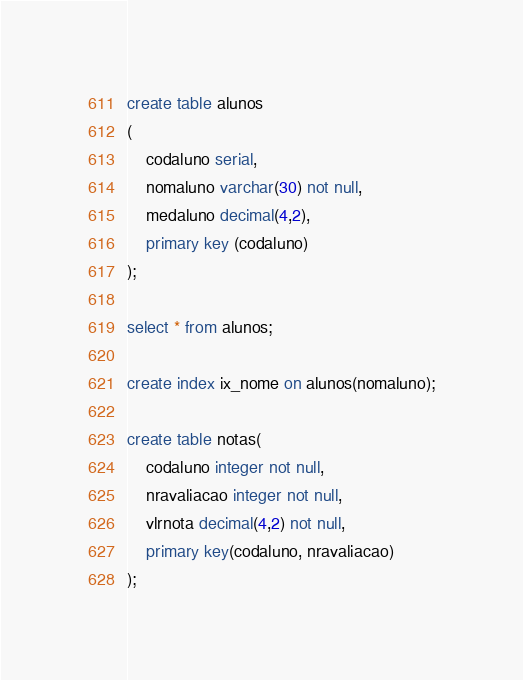Convert code to text. <code><loc_0><loc_0><loc_500><loc_500><_SQL_>create table alunos
(
	codaluno serial,
	nomaluno varchar(30) not null,
	medaluno decimal(4,2),
	primary key (codaluno)
);

select * from alunos;

create index ix_nome on alunos(nomaluno);

create table notas(
	codaluno integer not null,
	nravaliacao integer not null,
	vlrnota decimal(4,2) not null,
	primary key(codaluno, nravaliacao)
);
</code> 